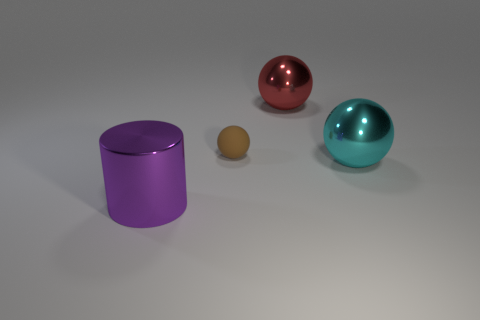Add 2 big green rubber cubes. How many objects exist? 6 Subtract all balls. How many objects are left? 1 Add 1 red metal spheres. How many red metal spheres are left? 2 Add 4 small cyan cylinders. How many small cyan cylinders exist? 4 Subtract 0 gray balls. How many objects are left? 4 Subtract all small gray rubber cubes. Subtract all cyan things. How many objects are left? 3 